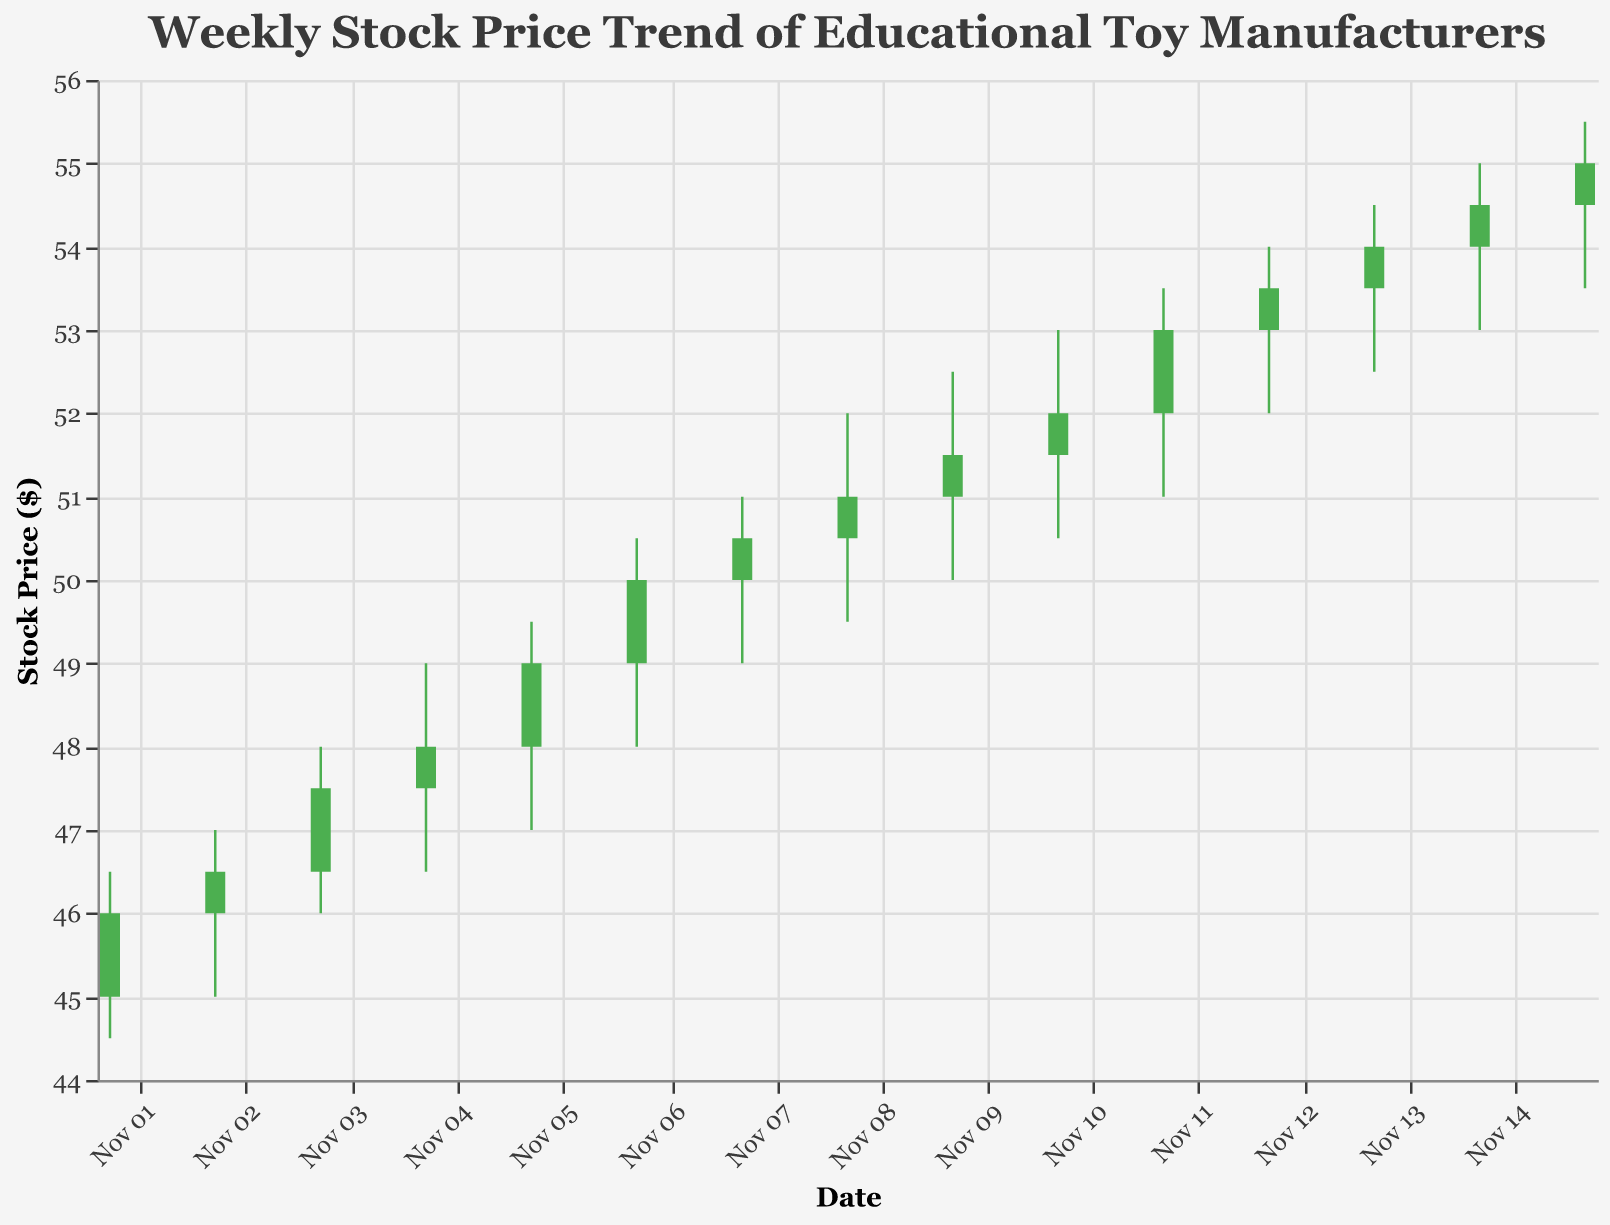What is the title of the figure? The title of the figure is typically displayed at the top, formatted in a larger font size. In this case, the title is clearly stated at the top of the plot.
Answer: Weekly Stock Price Trend of Educational Toy Manufacturers What is the range of the y-axis in the figure? The range of the y-axis can be observed by looking at the minimum and maximum values labeled along the y-axis. Here, it ranges from 44 to 56.
Answer: 44 to 56 On which date did the stock price have the highest closing value? To determine this, observe the closing prices for each date and identify the maximum value. The peak closing value is 55.00, which occurred on 2023-11-15.
Answer: 2023-11-15 Which company had the highest trading volume and on which date? By examining the volume data for each date, the highest volume is 2900000, belonging to VTech on 2023-11-15.
Answer: VTech on 2023-11-15 How many days did the closing price end higher than the opening price? Count the data bars with green color, indicating closing prices higher than the opening prices. There are 15 instances in the dataset.
Answer: 11 days Which company’s stock price increased the most over a single day, and by how much? Find the largest difference between the closing and opening prices for any company on any date. Playmobil’s stock price increased by 2.00 (53.00 - 51.00) on 2023-11-11.
Answer: Playmobil increased by 2.00 What was the lowest stock price (Low) recorded during the given period, and on which date? The lowest price observed on the plot is 44.50, which occurred on 2023-11-01.
Answer: 44.50 on 2023-11-01 Compare the trading volume on 2023-11-10 and 2023-11-11. Which day had a higher volume? Check the volume for both dates. 2023-11-10 had a volume of 2400000, whereas 2023-11-11 had a volume of 2500000. Thus, 2023-11-11 had a higher volume.
Answer: 2023-11-11 Did any company consistently have an increasing trend in their closing price across the days? Analyze the closing prices for any company across their active days. Playmobil consistently increased from 50.00 to 53.50 from 2023-11-07 to 2023-11-11.
Answer: Playmobil 